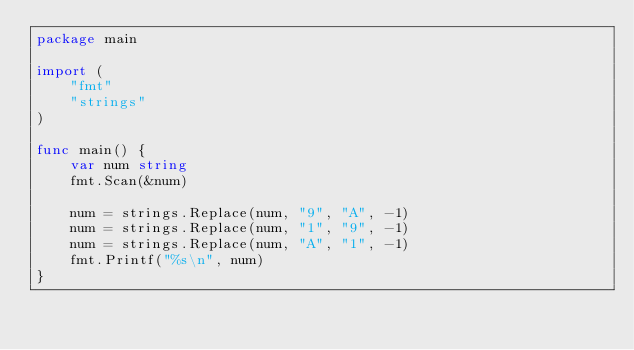<code> <loc_0><loc_0><loc_500><loc_500><_Go_>package main

import (
	"fmt"
	"strings"
)

func main() {
	var num string
	fmt.Scan(&num)

	num = strings.Replace(num, "9", "A", -1)
	num = strings.Replace(num, "1", "9", -1)
	num = strings.Replace(num, "A", "1", -1)
	fmt.Printf("%s\n", num)
}
</code> 